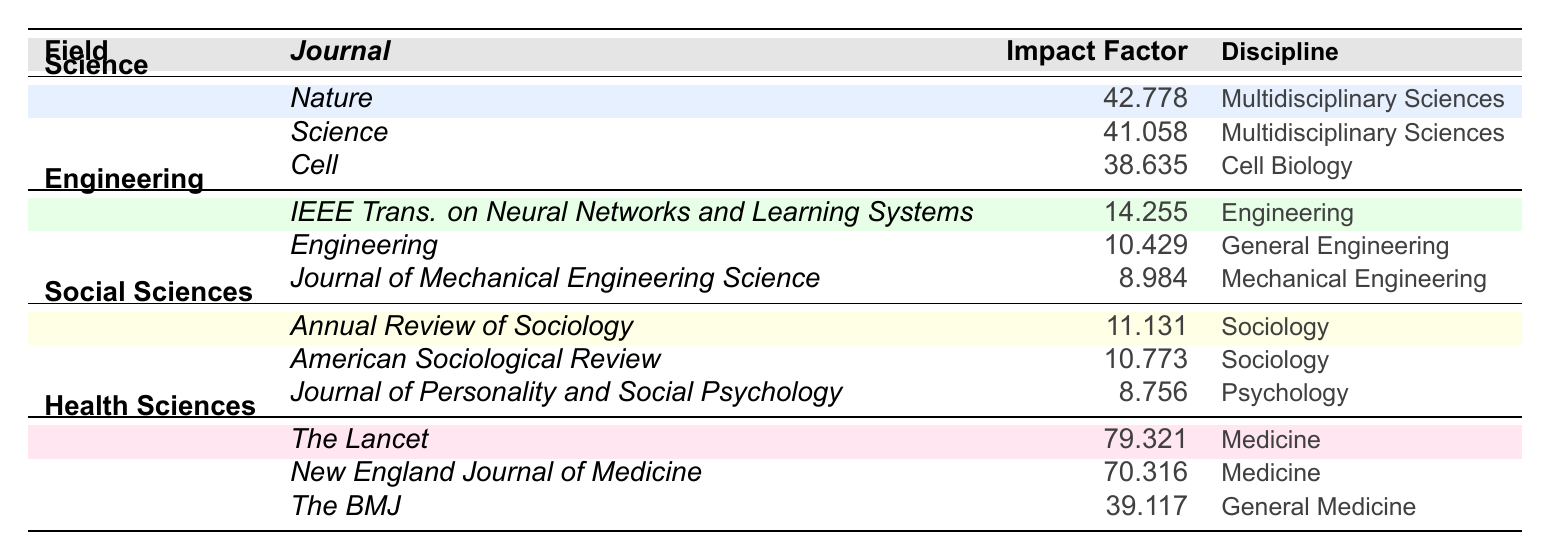What is the highest impact factor listed in the table? The highest impact factor can be found by scanning the table for the maximum numerical value noted in the "Impact Factor" column. In this case, that value is 79.321 for "The Lancet" in the field of Health Sciences.
Answer: 79.321 Which journal in the "Science" field has the lowest impact factor? To find the journal with the lowest impact factor in the Science field, we compare the impact factors of "Nature" (42.778), "Science" (41.058), and "Cell" (38.635). "Cell," with an impact factor of 38.635, is the lowest.
Answer: Cell Is there a journal in the "Social Sciences" discipline that has an impact factor greater than 10? We can check the impact factors of the journals listed under Social Sciences: "Annual Review of Sociology" (11.131) and "American Sociological Review" (10.773) both exceed 10. Therefore, the answer is yes.
Answer: Yes What is the average impact factor of journals in the "Engineering" field? First, we sum the impact factors of the journals in the Engineering field: 14.255 (IEEE Transactions on Neural Networks and Learning Systems) + 10.429 (Engineering) + 8.984 (Journal of Mechanical Engineering Science) = 33.668. Then, divide by the number of journals, which is 3, resulting in an average impact factor of 33.668 / 3 = 11.22266667, which we can round to 11.223.
Answer: 11.223 Are there any journals in the "Health Sciences" discipline with an impact factor less than 50? We look at the impact factors for the journals in Health Sciences: "The Lancet" (79.321), "New England Journal of Medicine" (70.316), and "The BMJ" (39.117). The only journal that is below 50 is "The BMJ." Thus, the answer is yes.
Answer: Yes Which discipline has the highest average impact factor when considering all its journals? To determine the average impact factor for each discipline, we need to calculate the averages. For Science: (42.778 + 41.058 + 38.635) / 3 = 40.15767. For Engineering: (14.255 + 10.429 + 8.984) / 3 = 11.22267. For Social Sciences: (11.131 + 10.773 + 8.756) / 3 = 10.88667. For Health Sciences: (79.321 + 70.316 + 39.117) / 3 = 62.25133. The highest average is 62.25133 for Health Sciences.
Answer: Health Sciences 